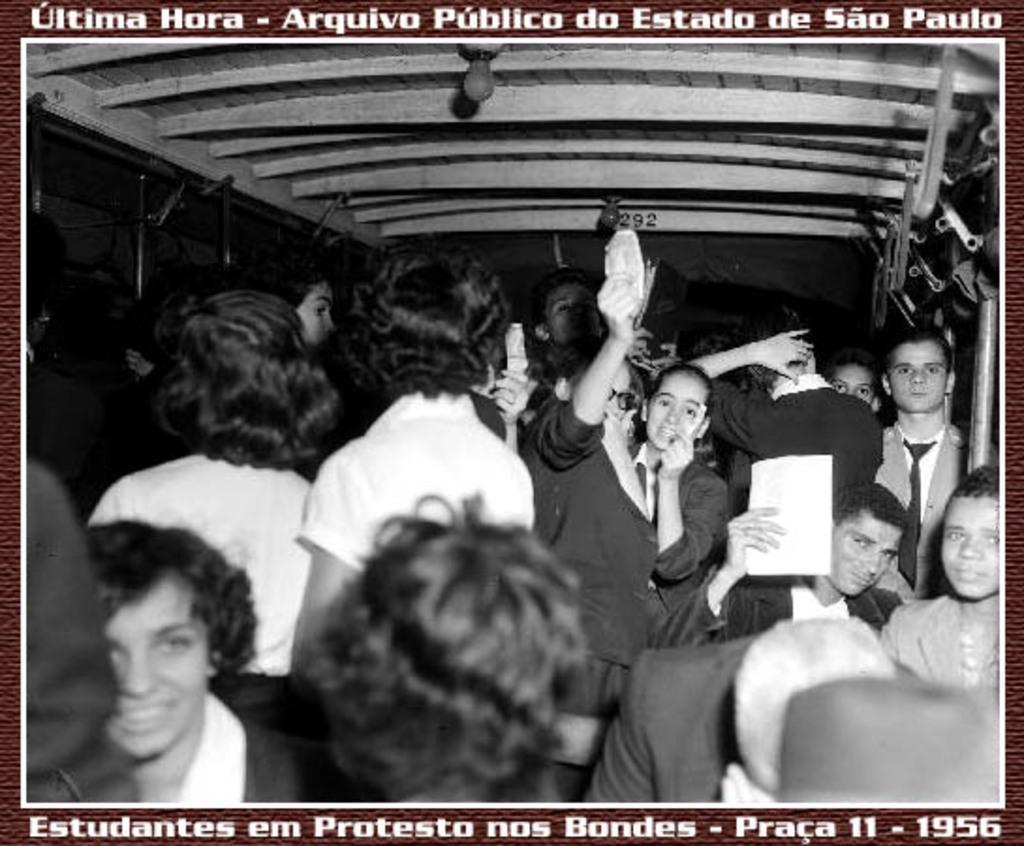Could you give a brief overview of what you see in this image? In this image, we can see the photocopy of a few people. We can also see some text at the top and the bottom of the picture. 